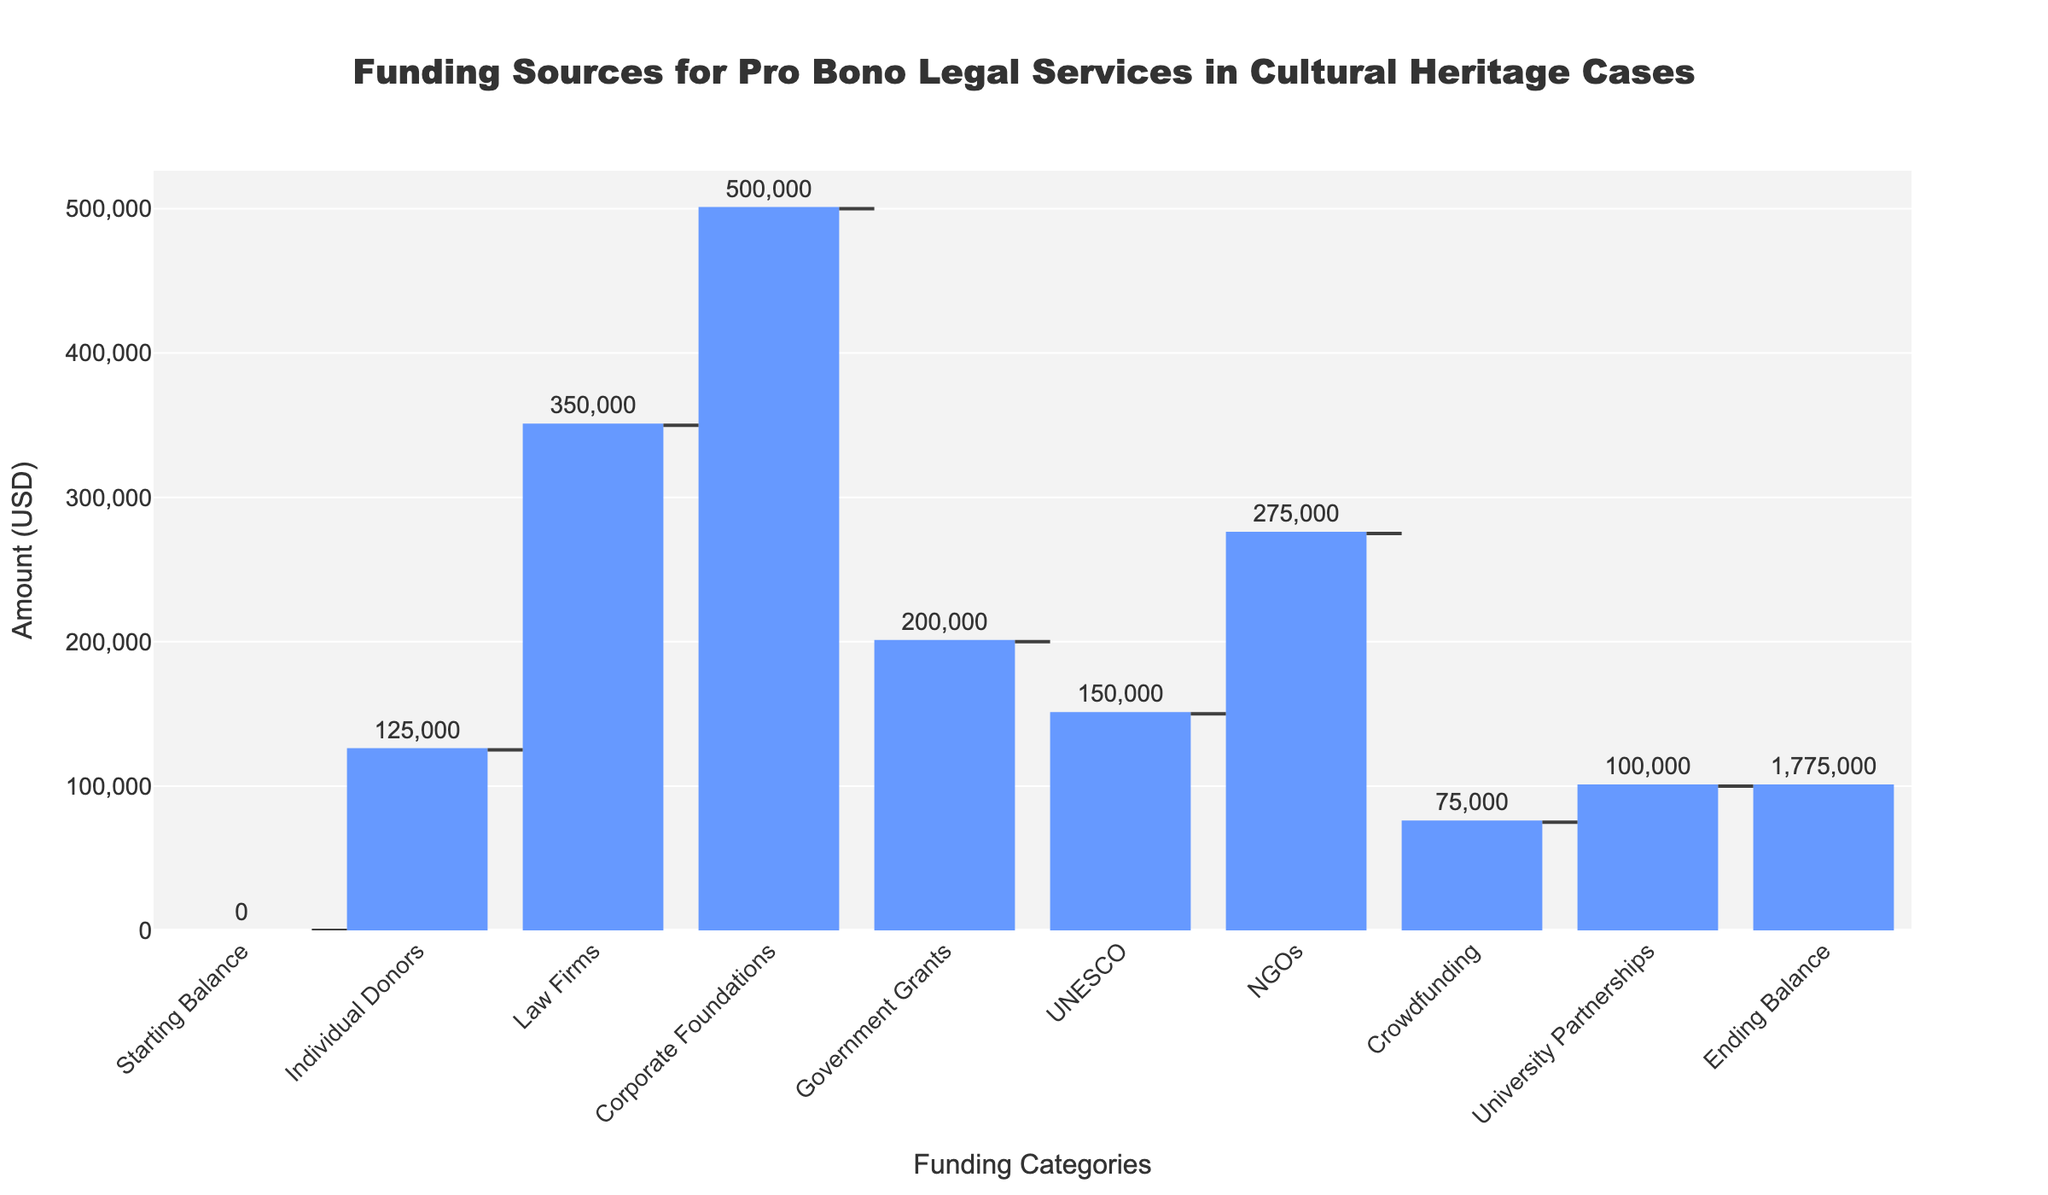What is the main title of the figure? The main title is located at the top center of the figure and typically serves as a summary of the chart's content
Answer: Funding Sources for Pro Bono Legal Services in Cultural Heritage Cases What category contributes the most to the ending balance? To determine the largest contributor, check all individual donor categories and compare their values
Answer: Corporate Foundations How many funding categories are listed, excluding the starting and ending balance? Counting all categories between the starting and ending balance in the x-axis
Answer: Seven What is the amount provided by NGOs? Locate the category labeled "NGOs" and read the value associated with it
Answer: 275,000 If we sum the contributions from Law Firms and Government Grants, what is the total? Add the values from the Law Firms and Government Grants categories: 350,000 + 200,000
Answer: 550,000 Which categories show a positive contribution to the funding balance? Identify categories with positive values which represent an increase in funding
Answer: Individual Donors, Law Firms, Corporate Foundations, Government Grants, UNESCO, NGOs, Crowdfunding, University Partnerships How much more does the Corporate Foundations category contribute compared to the Individual Donors category? Subtract the value for Individual Donors from the value for Corporate Foundations: 500,000 - 125,000
Answer: 375,000 What is the final (ending) balance shown in the chart? The ending balance is the sum of all contributions and is labeled at the last position on the x-axis
Answer: 1,775,000 Compare the amounts given by UNESCO and University Partnerships. Which one is higher and by how much? Subtract the value for University Partnerships from the value for UNESCO to find the difference: 150,000 - 100,000
Answer: UNESCO by 50,000 If the funding from Crowdfunding was doubled, what would the new total ending balance be? Double the Crowdfunding amount and add it to the original ending balance: 1,775,000 + 75,000
Answer: 1,850,000 